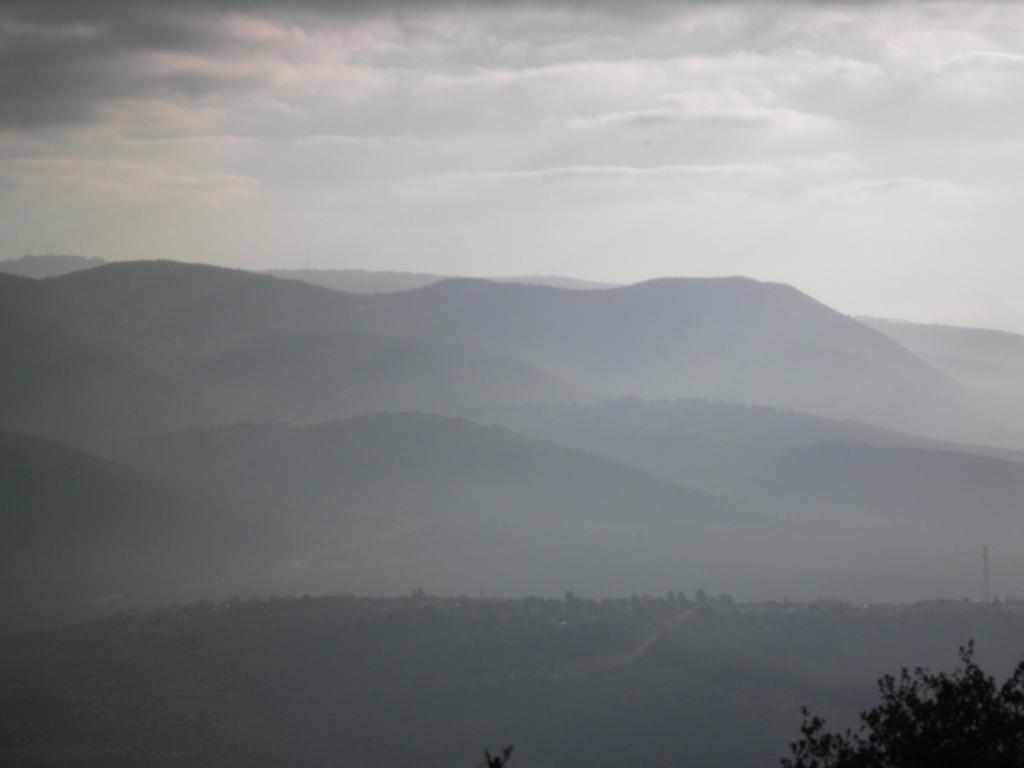Can you describe this image briefly? The picture consists of hills and trees. Sky is cloudy. 